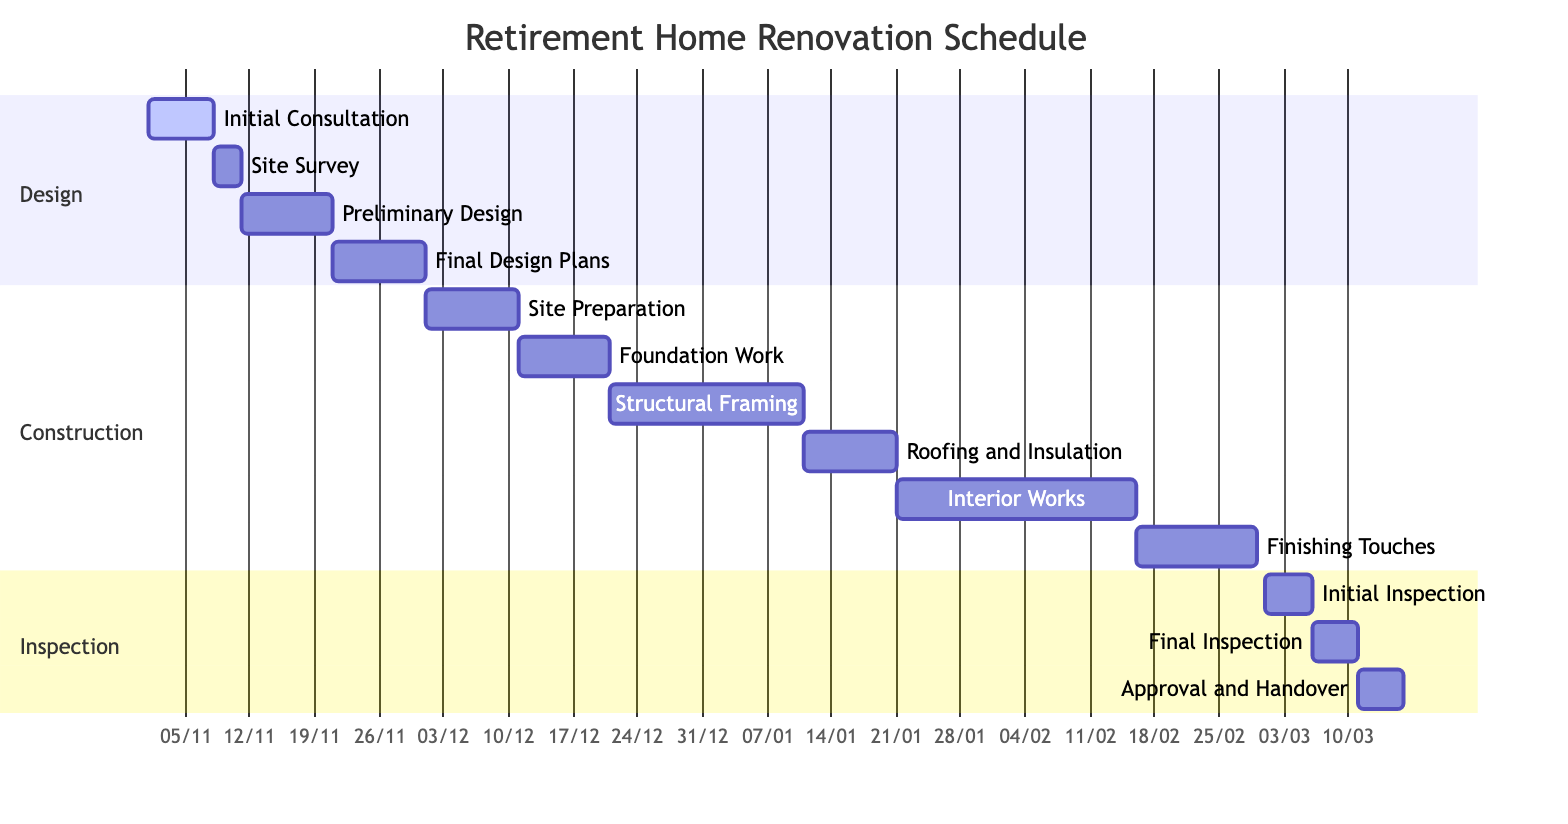What is the duration of the Preliminary Design phase? The Preliminary Design task starts on November 11, 2023, and ends on November 20, 2023. The duration can be calculated as the number of days from start to end, which is 10 days.
Answer: 10 days How many tasks are in the Construction phase? The Construction phase comprises six tasks listed in the chart: Site Preparation, Foundation Work, Structural Framing, Roofing and Insulation, Interior Works, and Finishing Touches. Counting them gives a total of six tasks.
Answer: 6 tasks Which task follows Site Survey? The task that follows Site Survey is Preliminary Design. The diagram indicates that Preliminary Design comes after Site Survey in the Design phase.
Answer: Preliminary Design What is the start date of Interior Works? The Interior Works task starts on January 21, 2024, as indicated in the Construction section of the diagram. The date is explicitly stated next to the task.
Answer: January 21, 2024 What is the total duration of the Inspection phase? The Inspection phase consists of three tasks: Initial Inspection (5 days), Final Inspection (5 days), and Approval and Handover (5 days). Adding these together gives a total duration of 15 days for the Inspection phase.
Answer: 15 days Which task has the longest duration in the Construction phase? The Structural Framing task is the longest, lasting for 21 days—from December 21, 2023, to January 10, 2024. This is verified by comparing the durations of all tasks in the Construction section.
Answer: Structural Framing What task is scheduled to start immediately after Roofing and Insulation? The task that starts immediately after Roofing and Insulation is Interior Works. The diagram shows that the Interior Works follows Roofing and Insulation without any time gaps.
Answer: Interior Works How many tasks are scheduled to be completed before March 1, 2024? Counting the tasks in both the Design and Construction phases, there are 8 tasks (4 in Design and 4 in Construction) that will be completed before March 1, 2024.
Answer: 8 tasks 